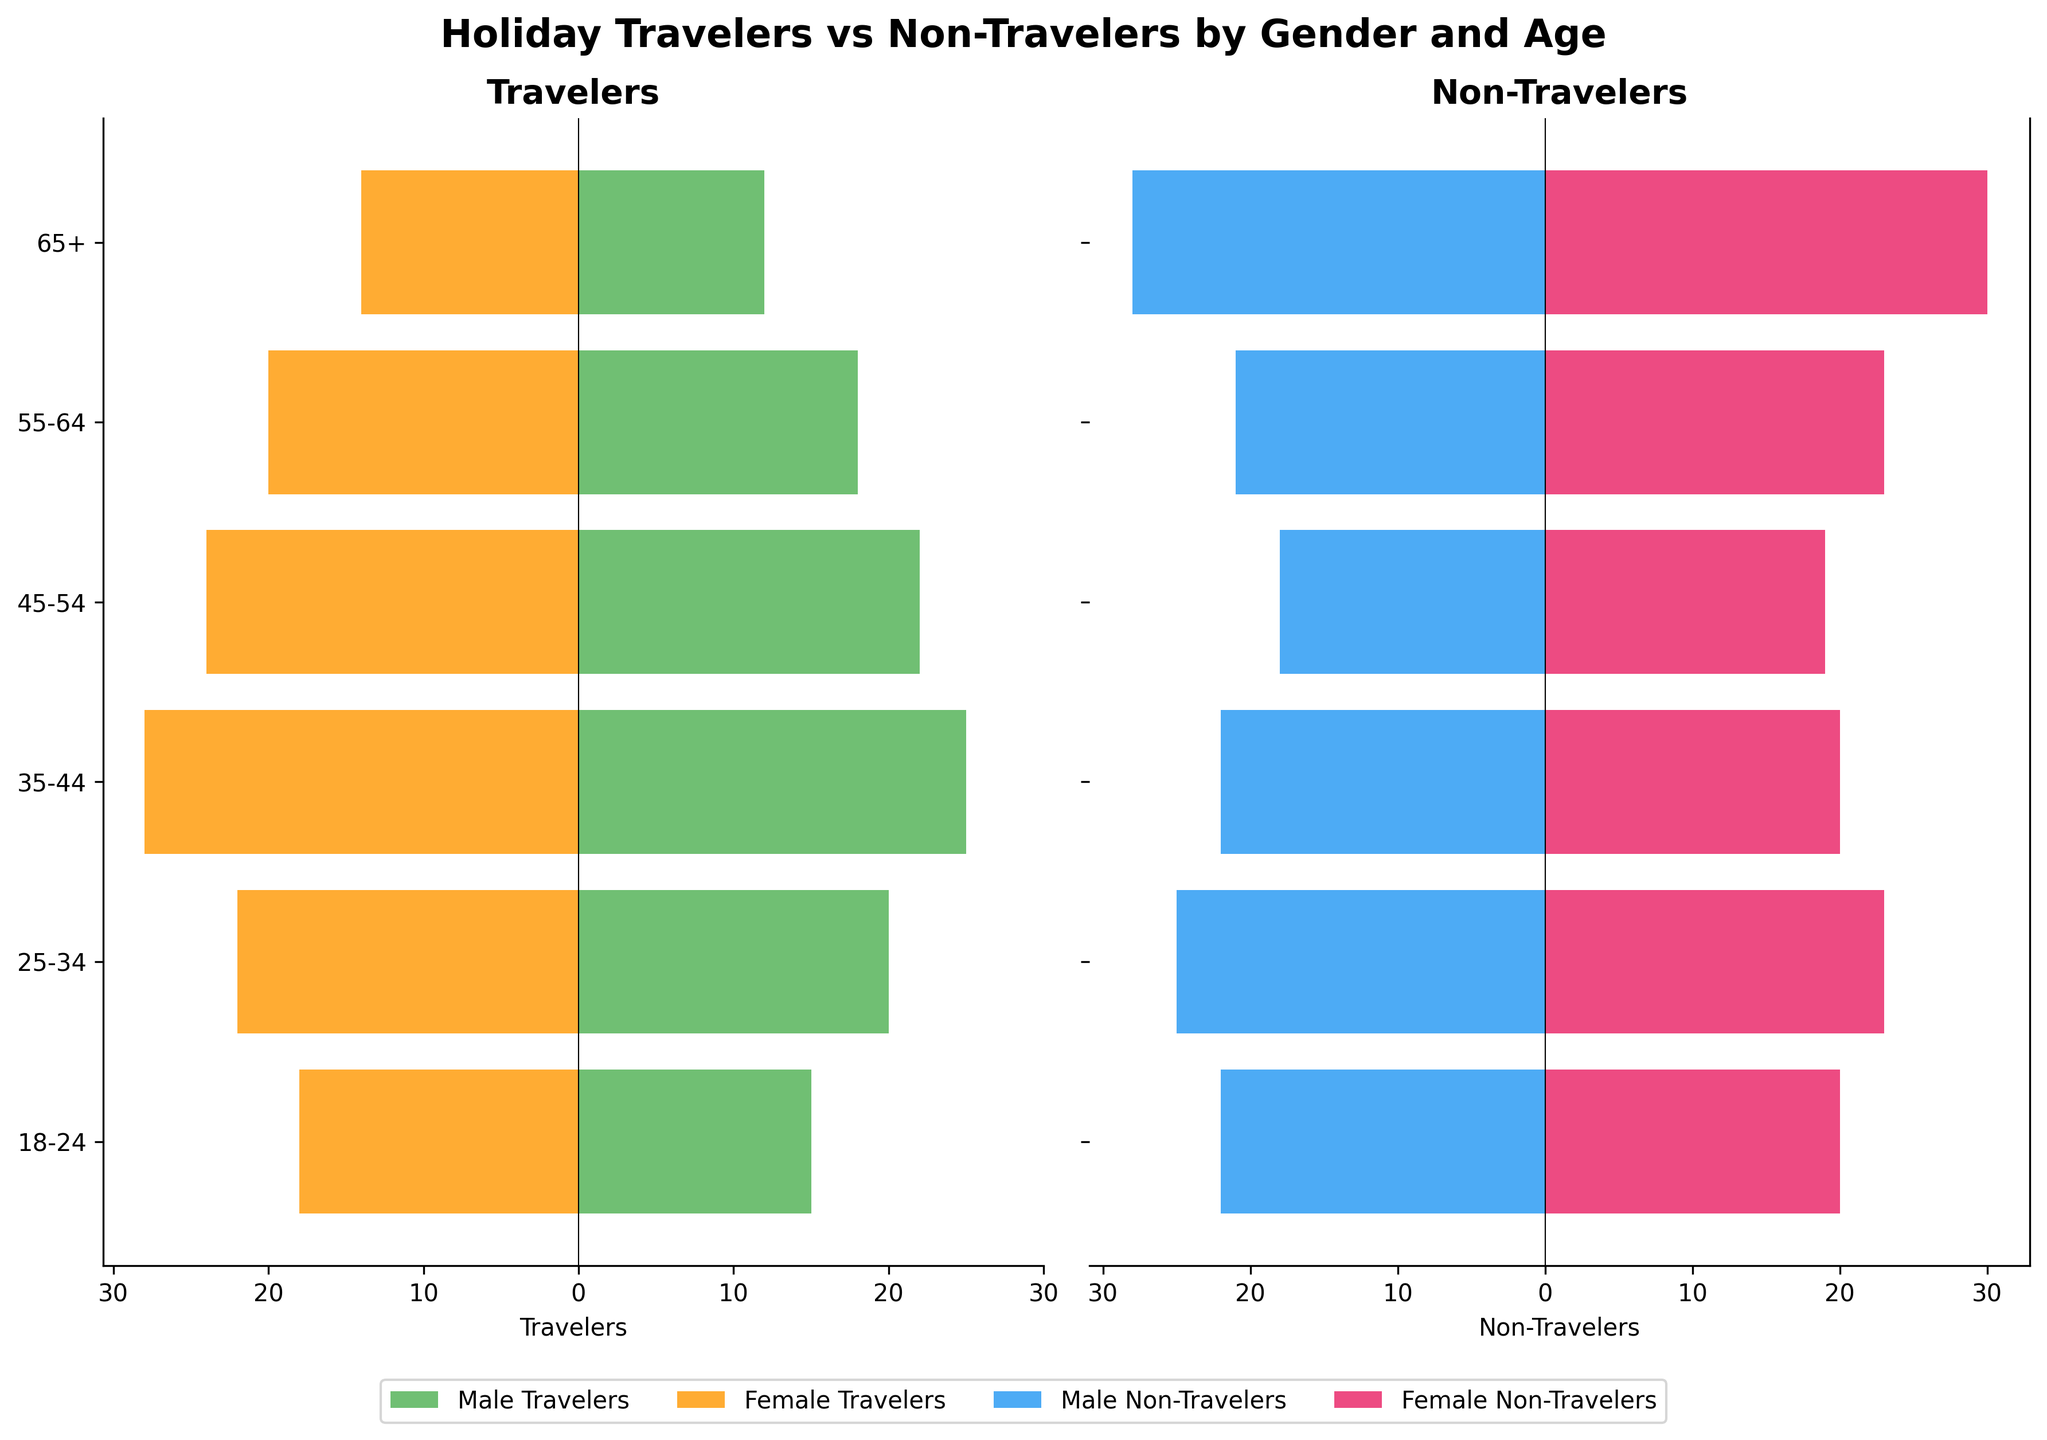What's the title of the figure? The title is located at the top of the figure and provides an overall description of what the data visualizes.
Answer: Holiday Travelers vs Non-Travelers by Gender and Age What age group has the highest number of male travelers? Identify the highest value in the male travelers' bar and match it to the corresponding age group on the y-axis.
Answer: 35-44 What is the total number of female non-travelers in the age groups 18-24 and 25-34 combined? Sum the values for female non-travelers in the age groups 18-24 (20) and 25-34 (23).
Answer: 43 Which gender travels more in the 55-64 age group, and by how much? Compare the values of male travelers (18) and female travelers (20) in the 55-64 age group, and calculate the difference.
Answer: Female, by 2 How do the numbers of travelers and non-travelers compare for males aged 65+? Compare the values of male travelers (12) and male non-travelers (28) in the 65+ age group.
Answer: Non-travelers are more by 16 In which age group do female non-travelers exceed female travelers the most? For each age group, find the difference between female non-travelers and female travelers, and identify the age group with the maximum difference.
Answer: 65+ What is the combined number of male travelers in the age groups 25-34 and 35-44? Add the values of male travelers in the age groups 25-34 (20) and 35-44 (25).
Answer: 45 Are 18-24 males more likely to travel or not? Compare the values of male travelers (15) and male non-travelers (22) in the 18-24 age group.
Answer: Not travel What is the average number of travelers (both genders) aged 45-54? Sum the numbers of male travelers (22) and female travelers (24) in the 45-54 age group, then divide by 2.
Answer: 23 Which age group has the closest numbers of travelers and non-travelers for females? For each age group, calculate the absolute difference between female travelers and female non-travelers, and find the smallest difference.
Answer: 45-54 